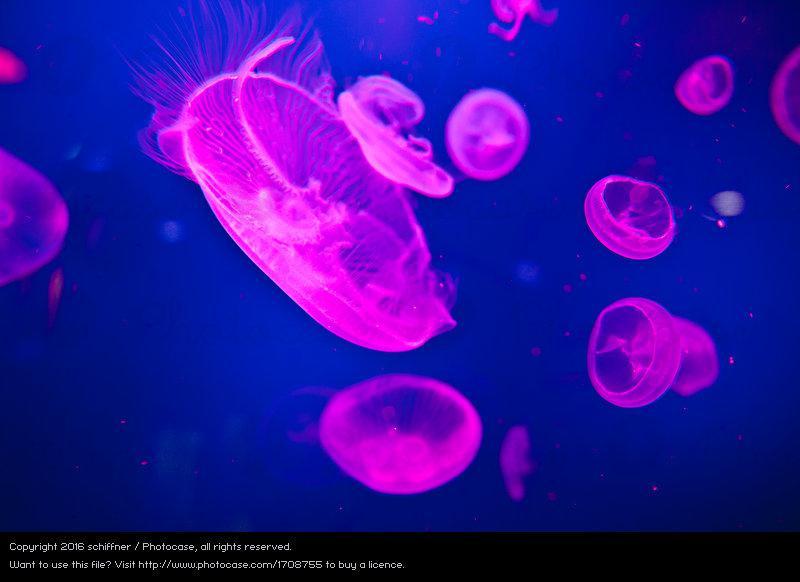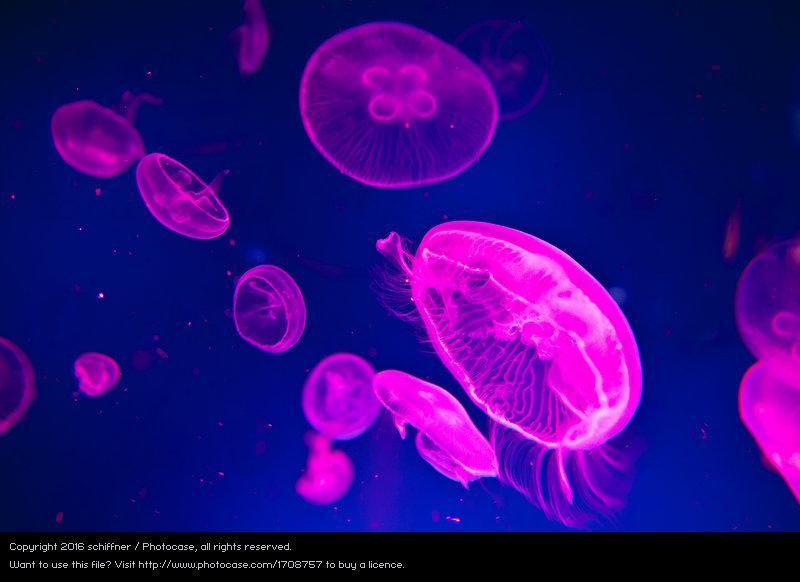The first image is the image on the left, the second image is the image on the right. For the images displayed, is the sentence "Neon pink jellyfish are shown in the right image." factually correct? Answer yes or no. Yes. The first image is the image on the left, the second image is the image on the right. Given the left and right images, does the statement "At least one jellyfish has tentacles longer than its body." hold true? Answer yes or no. No. The first image is the image on the left, the second image is the image on the right. Evaluate the accuracy of this statement regarding the images: "At least one image has jellyfish highlighted in pink.". Is it true? Answer yes or no. Yes. The first image is the image on the left, the second image is the image on the right. For the images displayed, is the sentence "At least one of the images shows pink jellyfish" factually correct? Answer yes or no. Yes. 